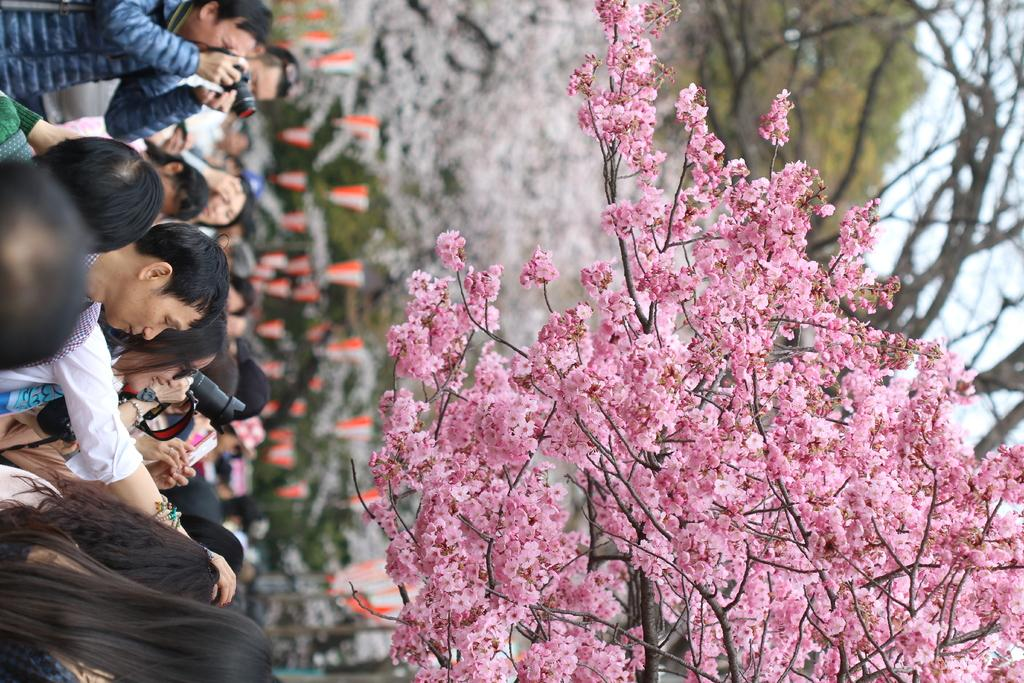What type of vegetation can be seen on the right side of the image? There are blossoms on the right side of the image. What is happening on the left side of the image? There is a crowd on the left side of the image. What are the people in the crowd holding? People are holding cameras in the image. What type of cork can be seen in the image? There is no cork present in the image. How many tomatoes are being held by the people in the crowd? There is no mention of tomatoes in the image; people are holding cameras instead. 